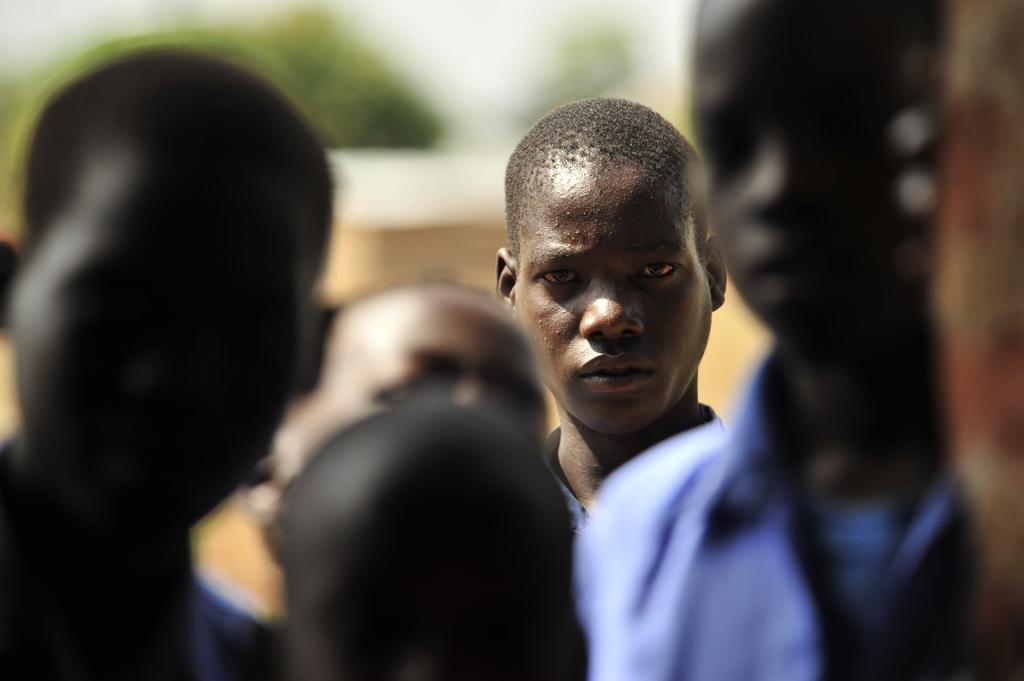What is the main focus of the image? There are people in the center of the image. Can you describe the background of the image? The background of the image is blurred. Can you see a bee flying near the people in the image? There is no bee visible in the image. Is there a veil covering the people in the image? The provided facts do not mention a veil, so we cannot determine if one is present. 